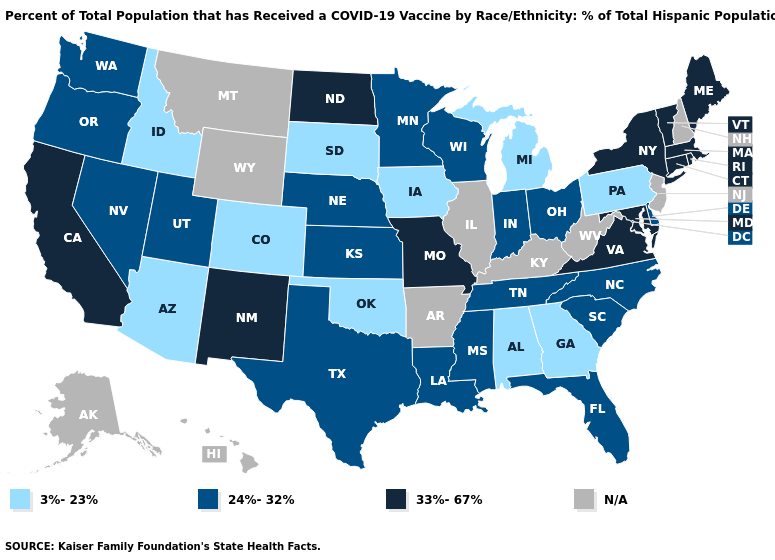What is the value of Ohio?
Keep it brief. 24%-32%. Name the states that have a value in the range 24%-32%?
Write a very short answer. Delaware, Florida, Indiana, Kansas, Louisiana, Minnesota, Mississippi, Nebraska, Nevada, North Carolina, Ohio, Oregon, South Carolina, Tennessee, Texas, Utah, Washington, Wisconsin. Does the first symbol in the legend represent the smallest category?
Concise answer only. Yes. What is the value of Arkansas?
Write a very short answer. N/A. How many symbols are there in the legend?
Short answer required. 4. Does Michigan have the highest value in the MidWest?
Write a very short answer. No. Does Oklahoma have the lowest value in the USA?
Quick response, please. Yes. What is the lowest value in states that border Pennsylvania?
Be succinct. 24%-32%. Among the states that border North Dakota , which have the lowest value?
Short answer required. South Dakota. Which states have the lowest value in the West?
Concise answer only. Arizona, Colorado, Idaho. Name the states that have a value in the range 33%-67%?
Be succinct. California, Connecticut, Maine, Maryland, Massachusetts, Missouri, New Mexico, New York, North Dakota, Rhode Island, Vermont, Virginia. Does Arizona have the lowest value in the West?
Short answer required. Yes. Name the states that have a value in the range 3%-23%?
Short answer required. Alabama, Arizona, Colorado, Georgia, Idaho, Iowa, Michigan, Oklahoma, Pennsylvania, South Dakota. Name the states that have a value in the range 33%-67%?
Give a very brief answer. California, Connecticut, Maine, Maryland, Massachusetts, Missouri, New Mexico, New York, North Dakota, Rhode Island, Vermont, Virginia. 